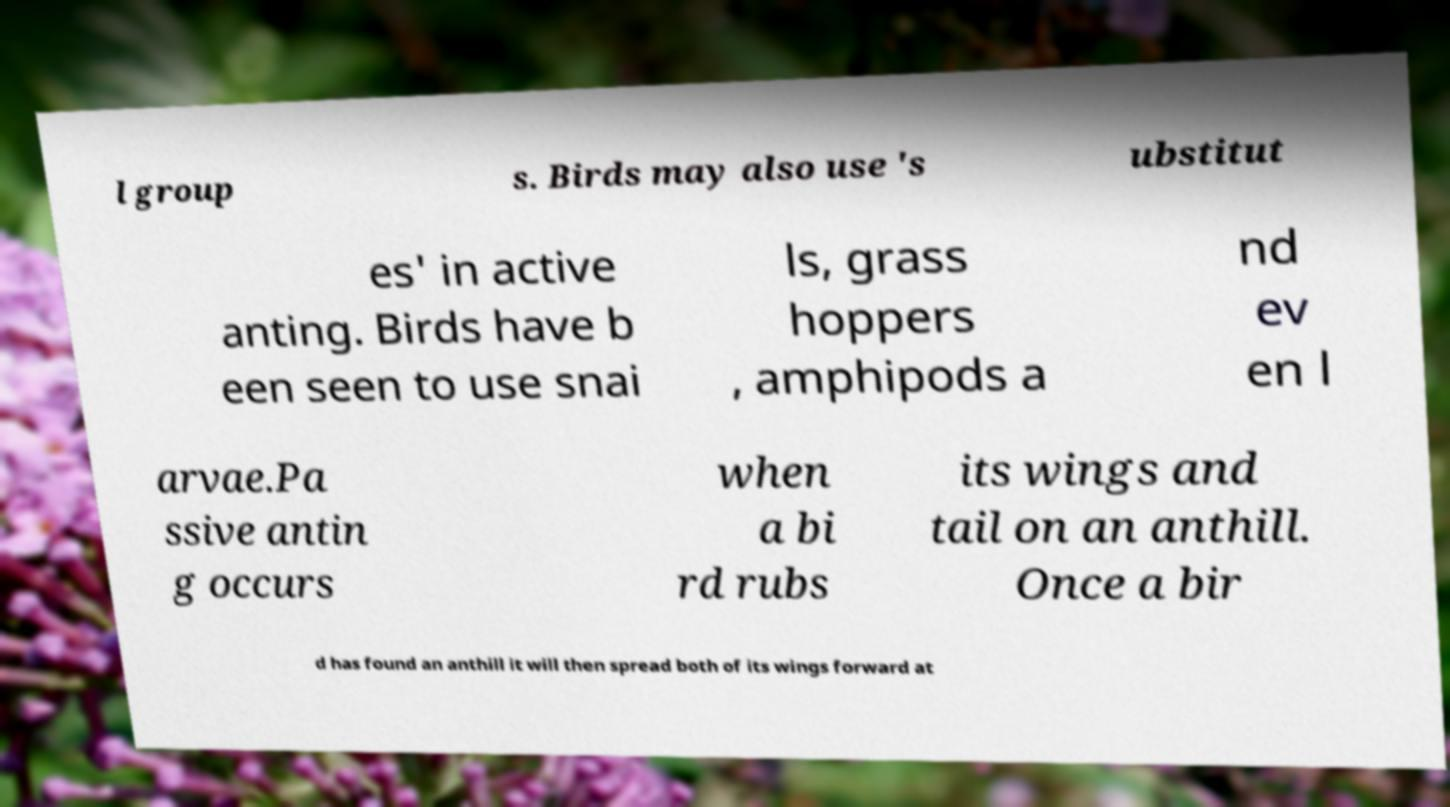Please read and relay the text visible in this image. What does it say? l group s. Birds may also use 's ubstitut es' in active anting. Birds have b een seen to use snai ls, grass hoppers , amphipods a nd ev en l arvae.Pa ssive antin g occurs when a bi rd rubs its wings and tail on an anthill. Once a bir d has found an anthill it will then spread both of its wings forward at 